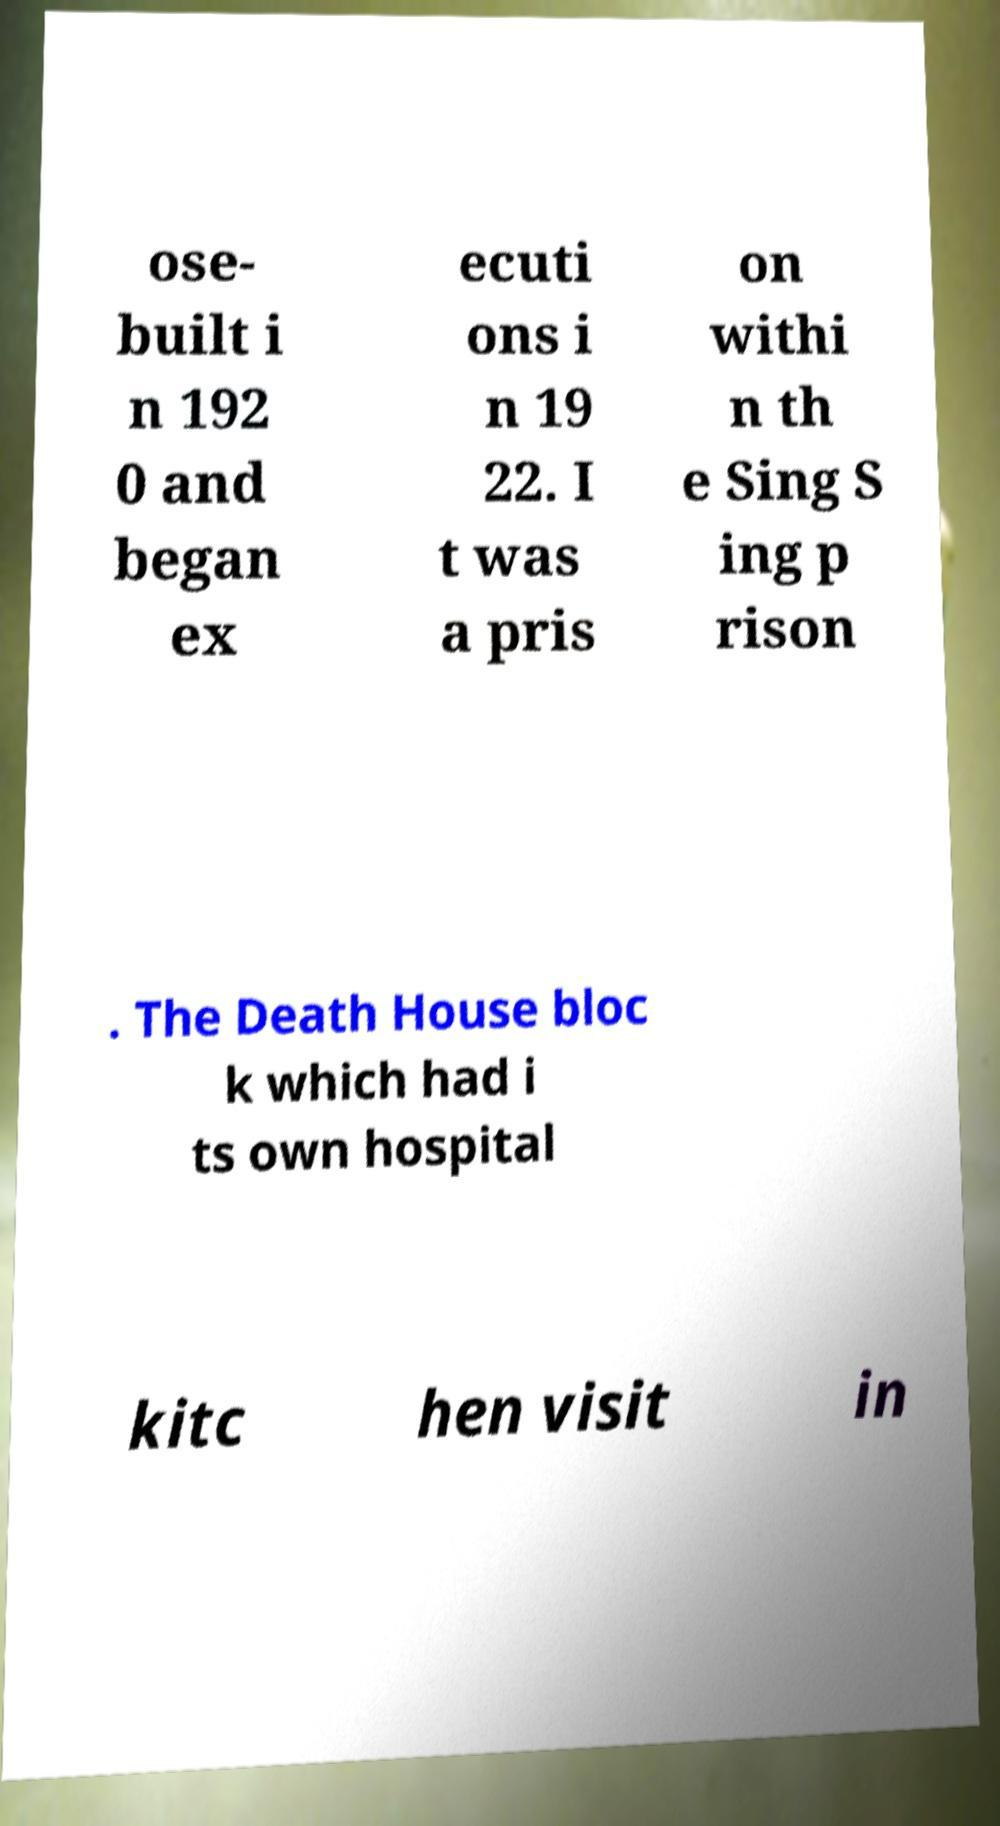I need the written content from this picture converted into text. Can you do that? ose- built i n 192 0 and began ex ecuti ons i n 19 22. I t was a pris on withi n th e Sing S ing p rison . The Death House bloc k which had i ts own hospital kitc hen visit in 